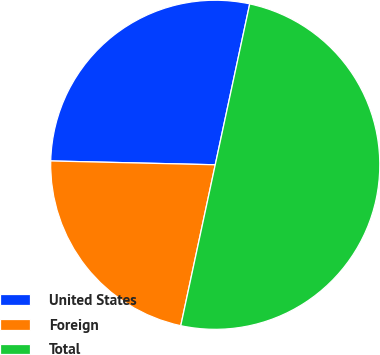<chart> <loc_0><loc_0><loc_500><loc_500><pie_chart><fcel>United States<fcel>Foreign<fcel>Total<nl><fcel>27.99%<fcel>22.01%<fcel>50.0%<nl></chart> 